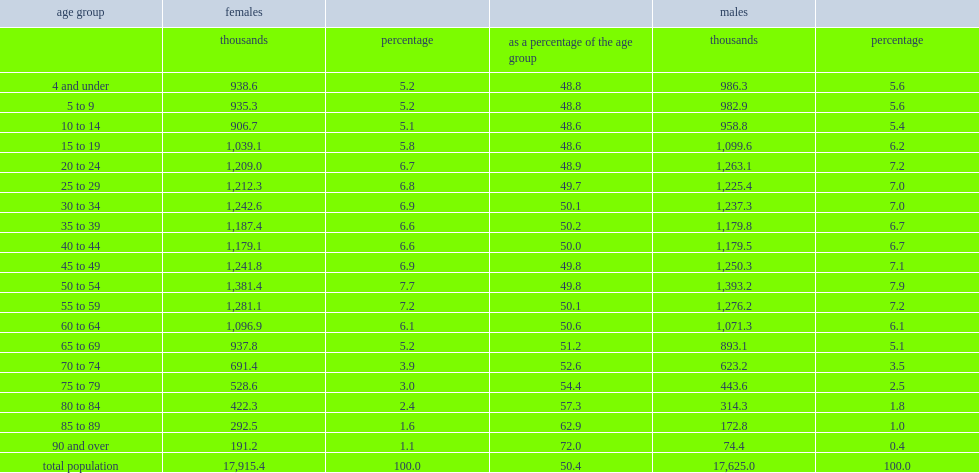What did women comprise of the population among individuals aged 55 to 59 in 2014? 50.1. What did women comprise of the population among individuals aged 85 to 89 in 2014? 62.9. What did women comprise of the population among individuals aged 90 and over in 2014? 72.0. 